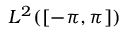<formula> <loc_0><loc_0><loc_500><loc_500>L ^ { 2 } ( \left [ - \pi , \pi \right ] )</formula> 